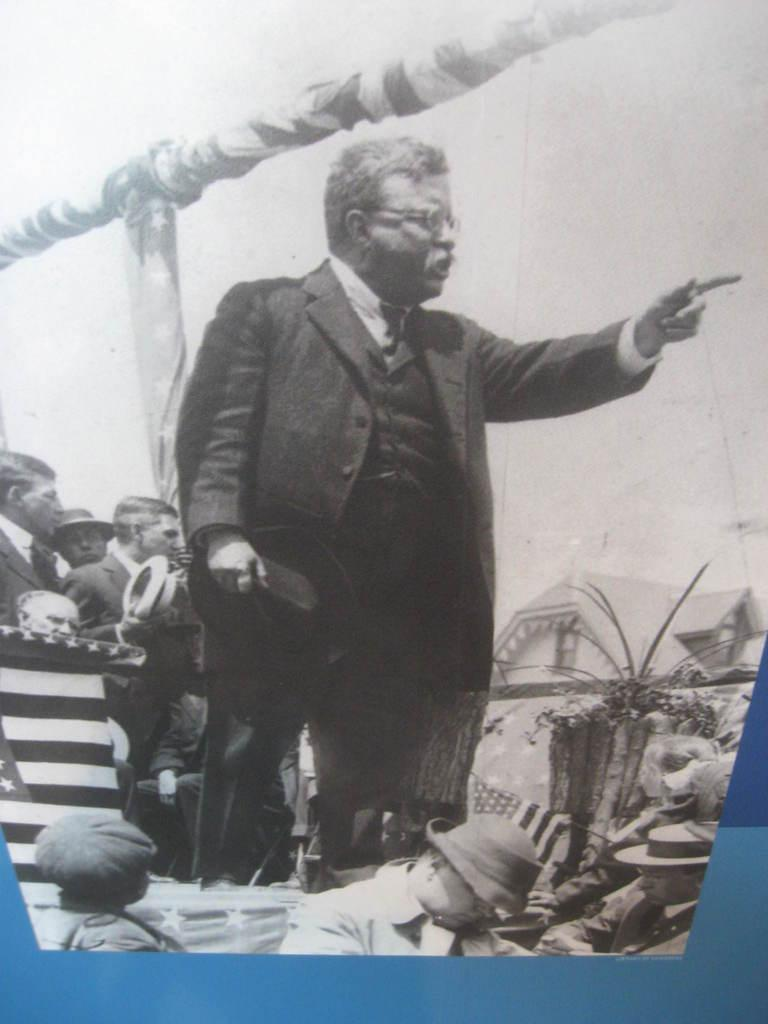What type of photo is in the image? The image contains a black and white photo. Who or what is the main subject of the photo? There is a person in the photo. Can you describe the surroundings of the person in the photo? There are groups of people behind the person in the photo, and a house and the sky are visible in the background. What else can be seen in the background of the photo? There are other unspecified things visible in the background of the photo. How many sheep are visible in the photo? There are no sheep visible in the photo; it is a black and white photo of a person with other people and a house in the background. Is there a park visible in the photo? There is no park visible in the photo; it features a person, groups of people, a house, and the sky in the background. 